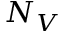<formula> <loc_0><loc_0><loc_500><loc_500>N _ { V }</formula> 